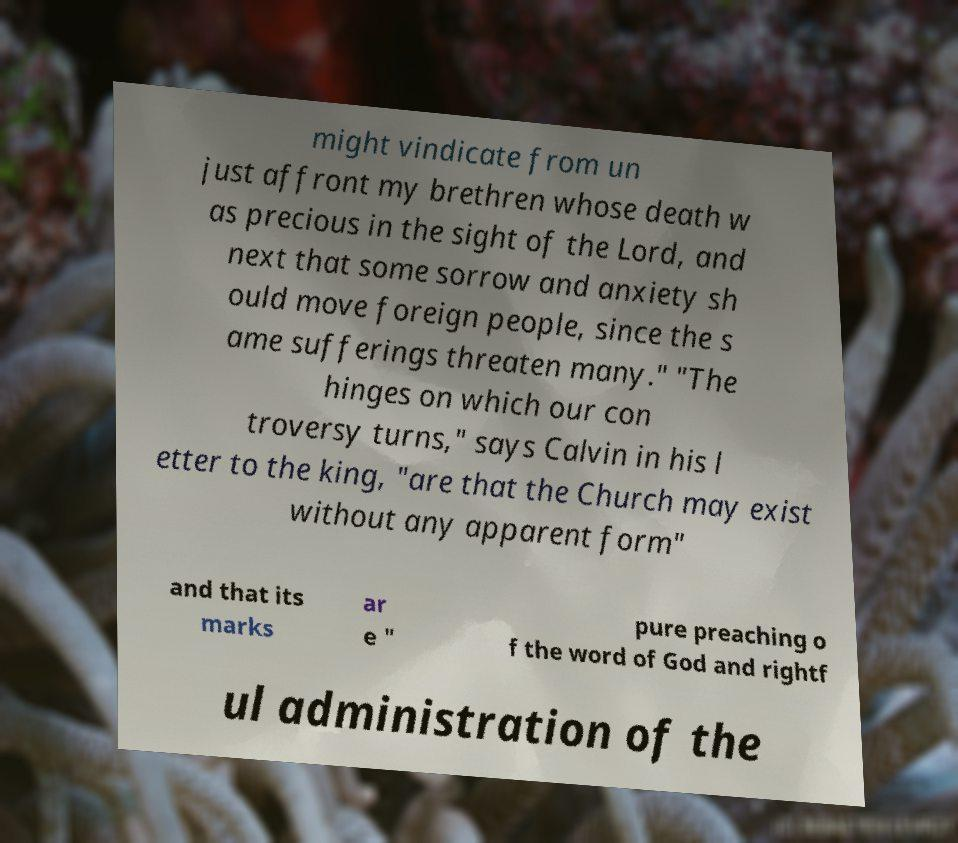Can you read and provide the text displayed in the image?This photo seems to have some interesting text. Can you extract and type it out for me? might vindicate from un just affront my brethren whose death w as precious in the sight of the Lord, and next that some sorrow and anxiety sh ould move foreign people, since the s ame sufferings threaten many." "The hinges on which our con troversy turns," says Calvin in his l etter to the king, "are that the Church may exist without any apparent form" and that its marks ar e " pure preaching o f the word of God and rightf ul administration of the 